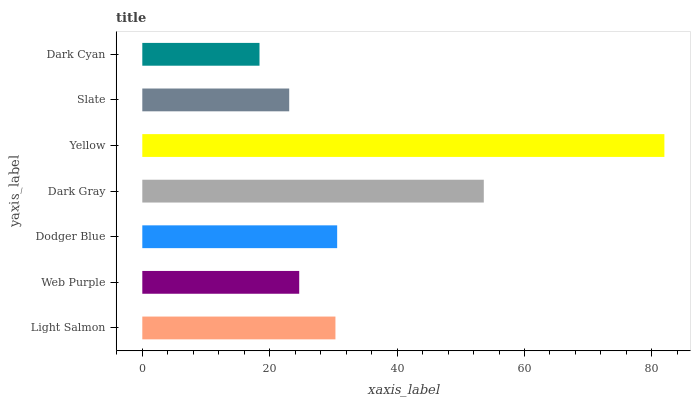Is Dark Cyan the minimum?
Answer yes or no. Yes. Is Yellow the maximum?
Answer yes or no. Yes. Is Web Purple the minimum?
Answer yes or no. No. Is Web Purple the maximum?
Answer yes or no. No. Is Light Salmon greater than Web Purple?
Answer yes or no. Yes. Is Web Purple less than Light Salmon?
Answer yes or no. Yes. Is Web Purple greater than Light Salmon?
Answer yes or no. No. Is Light Salmon less than Web Purple?
Answer yes or no. No. Is Light Salmon the high median?
Answer yes or no. Yes. Is Light Salmon the low median?
Answer yes or no. Yes. Is Yellow the high median?
Answer yes or no. No. Is Web Purple the low median?
Answer yes or no. No. 